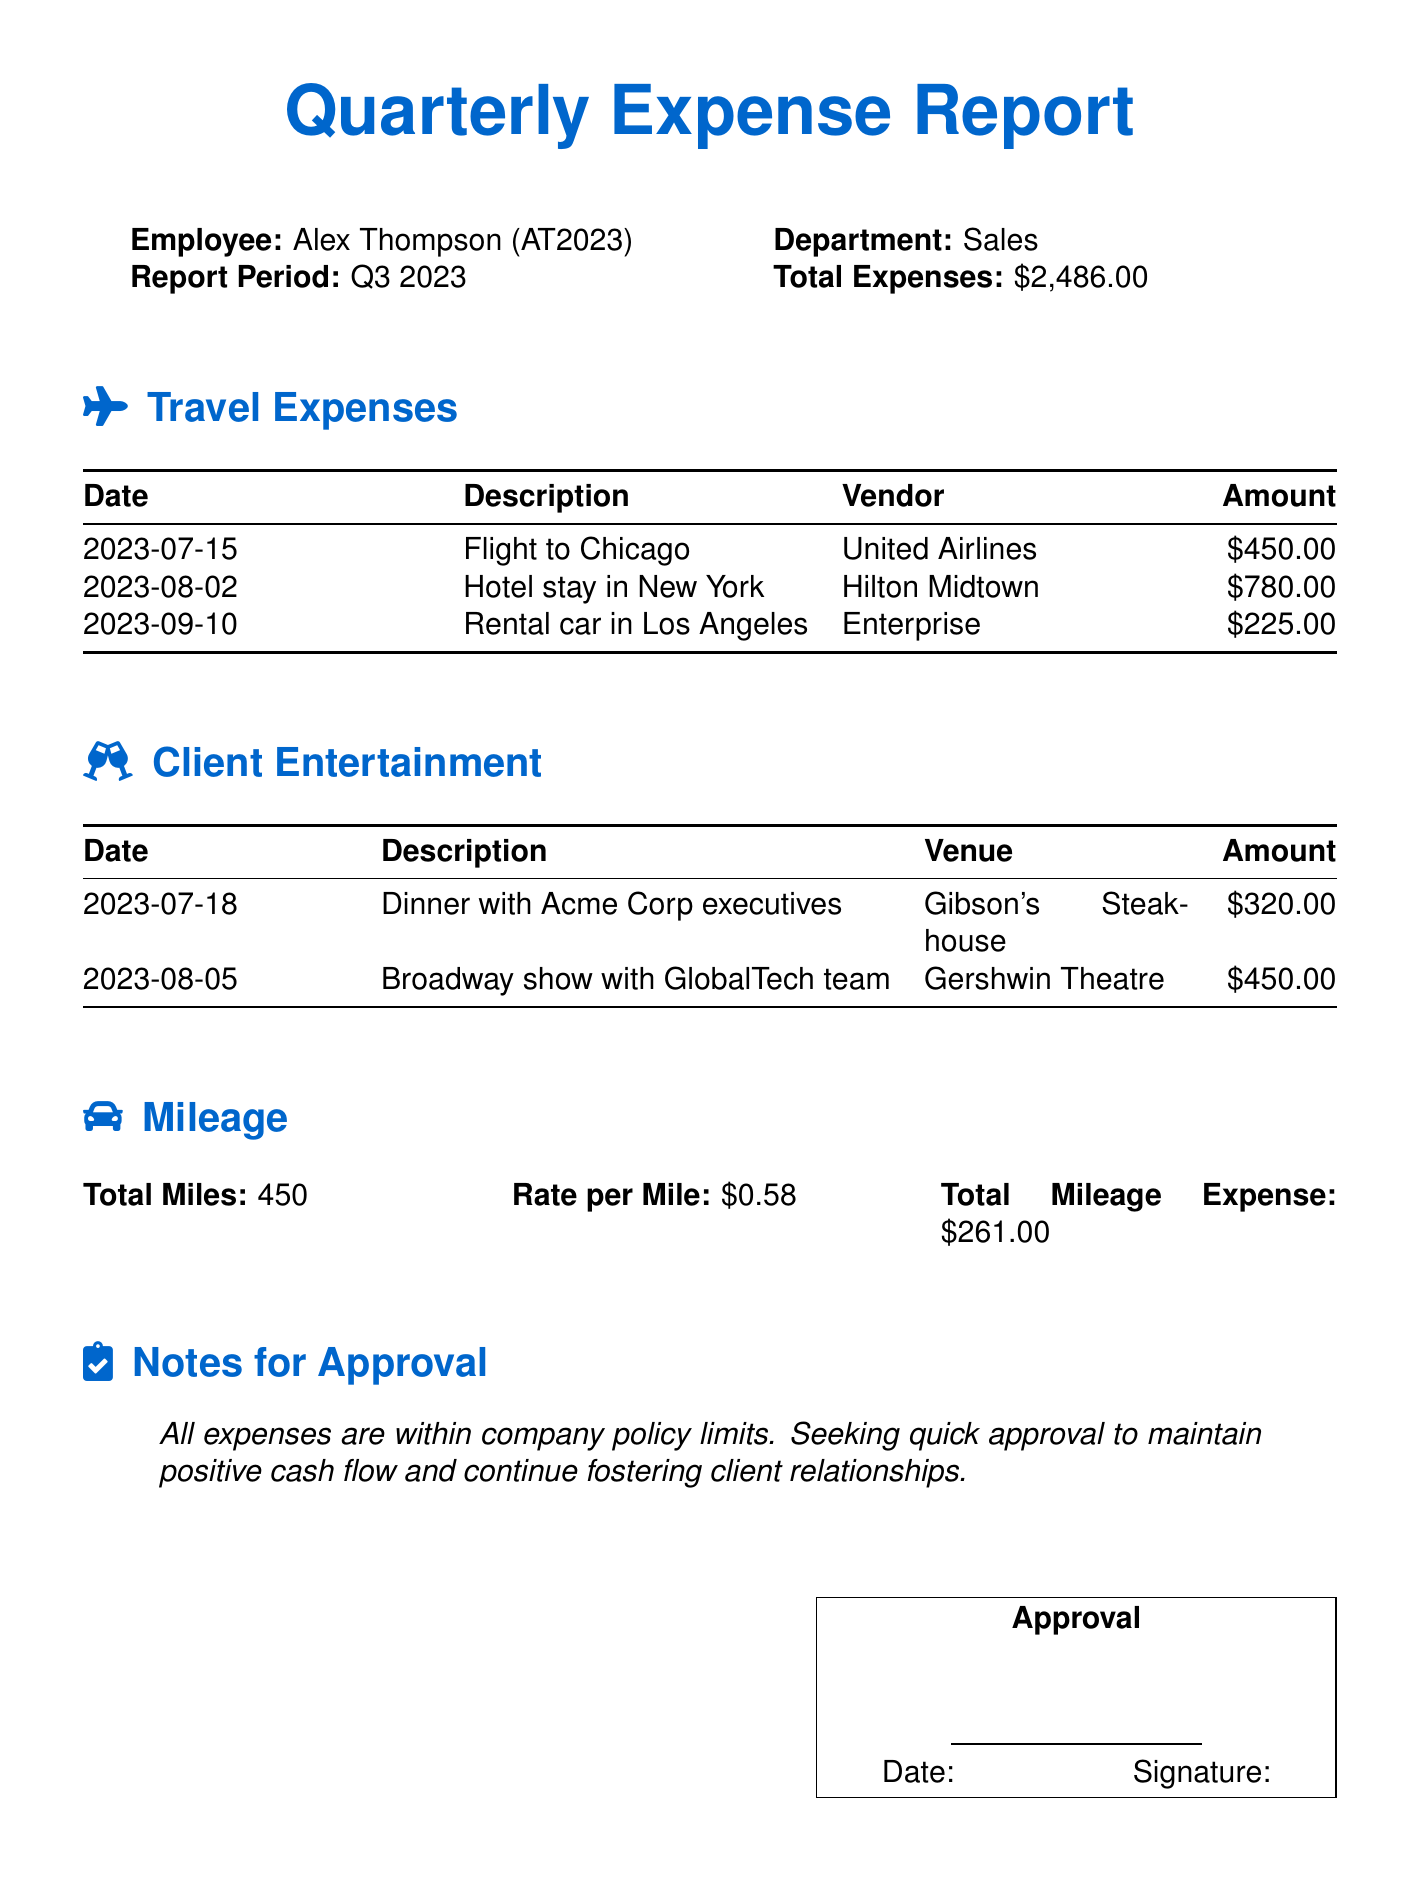what is the employee's name? The employee's name is mentioned in the document's header section.
Answer: Alex Thompson what is the total expenses amount? The total expenses amount is indicated in the report details.
Answer: $2,486.00 how much was spent on the flight to Chicago? The amount spent on the flight to Chicago is listed under travel expenses.
Answer: $450.00 which venue was used for client entertainment on July 18? The venue is provided in the client entertainment tabulation for the specified date.
Answer: Gibson's Steakhouse what is the total mileage expense? The total mileage expense calculation is summarized in the mileage section.
Answer: $261.00 how many people attended the Broadway show with GlobalTech team? The document does not specify the number of people attending the event, requiring an assumption.
Answer: Not specified what was the date of the hotel stay in New York? The date for the hotel stay is clearly indicated in the travel expenses section.
Answer: 2023-08-02 what is the rate per mile for mileage expenses? The rate per mile is outlined in the mileage section of the report.
Answer: $0.58 how many total miles were driven? The total miles driven is clearly stated in the mileage section.
Answer: 450 